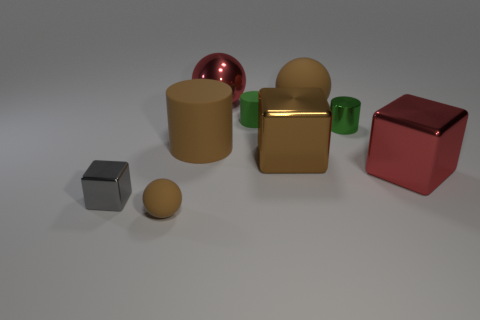Do the large cylinder and the large matte sphere have the same color?
Your answer should be compact. Yes. How many things are either small green rubber spheres or brown balls in front of the large red cube?
Give a very brief answer. 1. Is the number of rubber objects on the right side of the large matte cylinder the same as the number of tiny cylinders?
Provide a succinct answer. Yes. What shape is the tiny green thing that is made of the same material as the brown cylinder?
Give a very brief answer. Cylinder. Is there a cylinder of the same color as the small matte sphere?
Ensure brevity in your answer.  Yes. How many metallic things are either small green spheres or gray blocks?
Make the answer very short. 1. There is a object in front of the small gray metallic thing; what number of brown blocks are behind it?
Give a very brief answer. 1. What number of brown blocks have the same material as the red ball?
Offer a terse response. 1. How many large objects are brown matte balls or blue shiny things?
Offer a terse response. 1. There is a object that is both right of the gray cube and left of the brown matte cylinder; what is its shape?
Offer a terse response. Sphere. 